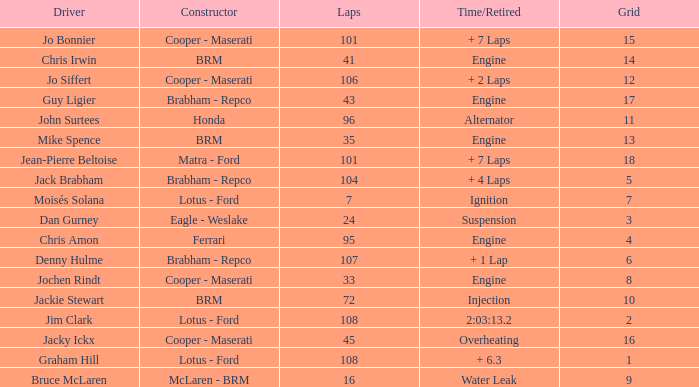What was the grid for suspension time/retired? 3.0. 